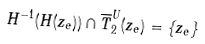<formula> <loc_0><loc_0><loc_500><loc_500>H ^ { - 1 } ( H ( z _ { e } ) ) \cap \overline { T } _ { 2 } ^ { U } ( z _ { e } ) = \{ z _ { e } \}</formula> 